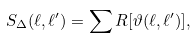Convert formula to latex. <formula><loc_0><loc_0><loc_500><loc_500>S _ { \Delta } ( \ell , \ell ^ { \prime } ) = \sum R [ \vartheta ( \ell , \ell ^ { \prime } ) ] ,</formula> 